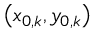<formula> <loc_0><loc_0><loc_500><loc_500>\left ( x _ { 0 , k } , y _ { 0 , k } \right )</formula> 